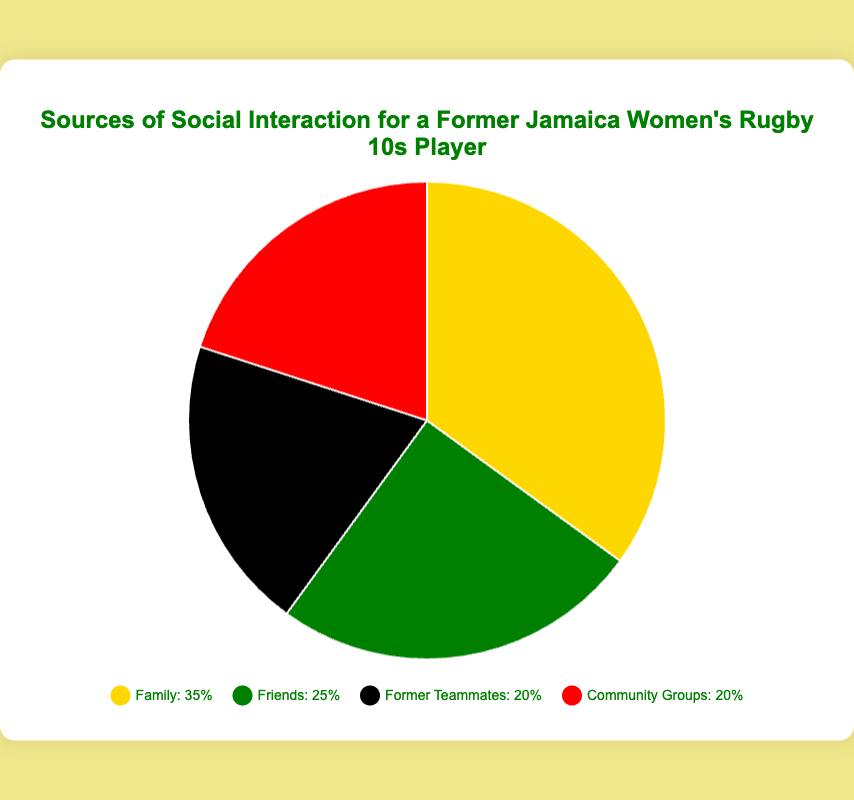What is the largest source of social interaction? The chart shows four categories: Family, Friends, Former Teammates, and Community Groups. The slice labeled 'Family' is the largest representing 35%.
Answer: Family Which two sources of social interaction are equally contributing? From the pie chart, 'Former Teammates' and 'Community Groups' both have the same size slices, each representing 20%.
Answer: Former Teammates and Community Groups How much more percentage does 'Family' contribute compared to 'Friends'? The 'Family' slice is 35% and the 'Friends' slice is 25%. Thus, Family contributes 35% - 25% = 10% more than Friends.
Answer: 10% What is the combined percentage of social interaction from 'Friends' and 'Community Groups'? The pie chart shows that 'Friends' represent 25% and 'Community Groups' represent 20%. Therefore, their combined percentage is 25% + 20% = 45%.
Answer: 45% Which color represents the 'Former Teammates' category? The visual attribute of the slice labeled 'Former Teammates' is black.
Answer: Black Arrange the sources of social interaction in descending order of their percentages. According to the chart, the percentages are: Family (35%), Friends (25%), Former Teammates (20%), and Community Groups (20%). Therefore, in descending order of percentages: Family, Friends, Former Teammates, Community Groups.
Answer: Family, Friends, Former Teammates, Community Groups What is the total percentage of social interactions attributed to contacts outside of the Family? Adding the percentages of Friends (25%), Former Teammates (20%), and Community Groups (20%) gives a total of 25% + 20% + 20% = 65%.
Answer: 65% Compare the size of the 'Community Groups' slice to the 'Friends' slice. The 'Community Groups' slice represents 20%, while 'Friends' is 25%. Therefore, the 'Friends' slice is larger than the 'Community Groups' slice.
Answer: Friends is larger than Community Groups What percentage of social interactions are attributable to 'Friends' and 'Former Teammates' combined, and how does this compare to the percentage from 'Family'? 'Friends' contribute 25% and 'Former Teammates' contribute 20%, so their combined percentage is 25% + 20% = 45%. This is 45% - 35% = 10% more than the 'Family' percentage.
Answer: 45% and 10% more than Family 